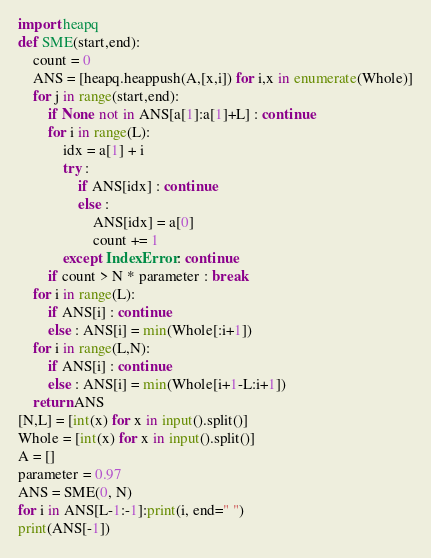Convert code to text. <code><loc_0><loc_0><loc_500><loc_500><_Python_>import heapq
def SME(start,end):
    count = 0
    ANS = [heapq.heappush(A,[x,i]) for i,x in enumerate(Whole)]
    for j in range(start,end):
        if None not in ANS[a[1]:a[1]+L] : continue
        for i in range(L):
            idx = a[1] + i
            try :
                if ANS[idx] : continue
                else :
                    ANS[idx] = a[0]
                    count += 1
            except IndexError : continue
        if count > N * parameter : break
    for i in range(L):
        if ANS[i] : continue
        else : ANS[i] = min(Whole[:i+1])
    for i in range(L,N):
        if ANS[i] : continue
        else : ANS[i] = min(Whole[i+1-L:i+1])
    return ANS
[N,L] = [int(x) for x in input().split()]
Whole = [int(x) for x in input().split()]
A = []
parameter = 0.97
ANS = SME(0, N)
for i in ANS[L-1:-1]:print(i, end=" ")
print(ANS[-1])</code> 